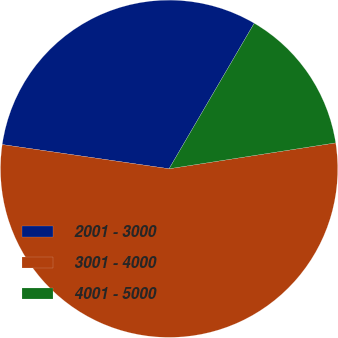<chart> <loc_0><loc_0><loc_500><loc_500><pie_chart><fcel>2001 - 3000<fcel>3001 - 4000<fcel>4001 - 5000<nl><fcel>31.13%<fcel>54.75%<fcel>14.12%<nl></chart> 